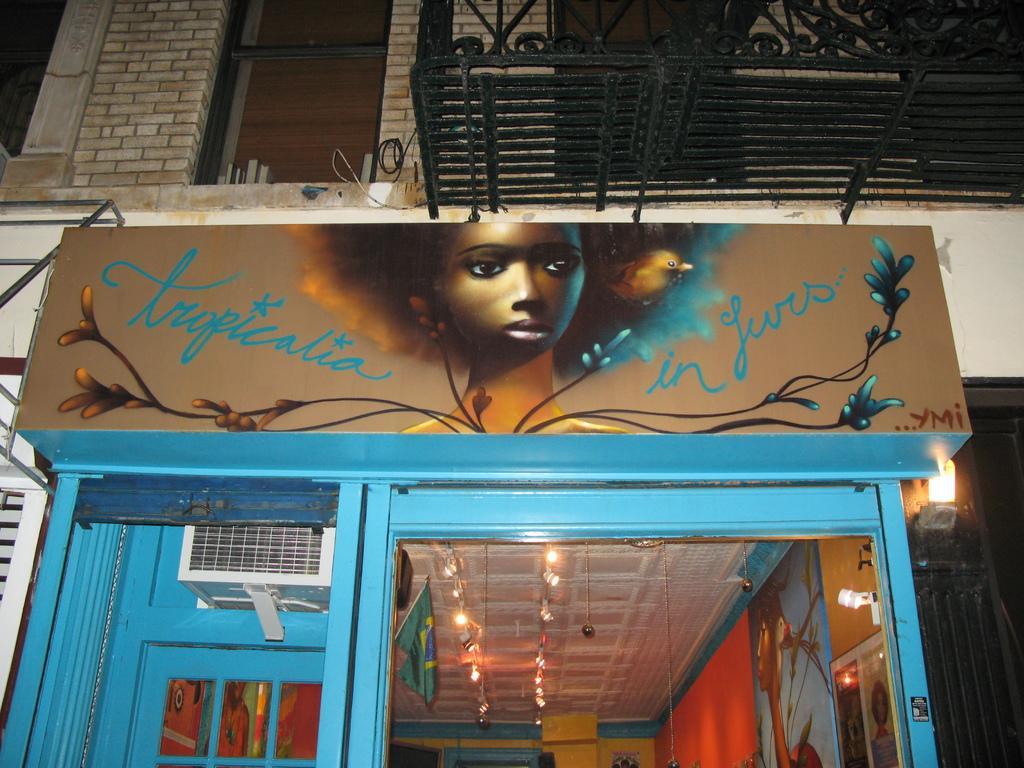Describe this image in one or two sentences. In this image in the center there is one building and a board. On the board there is some text and one women, and at the bottom there are some lights, air conditioner, flag and ceiling. 